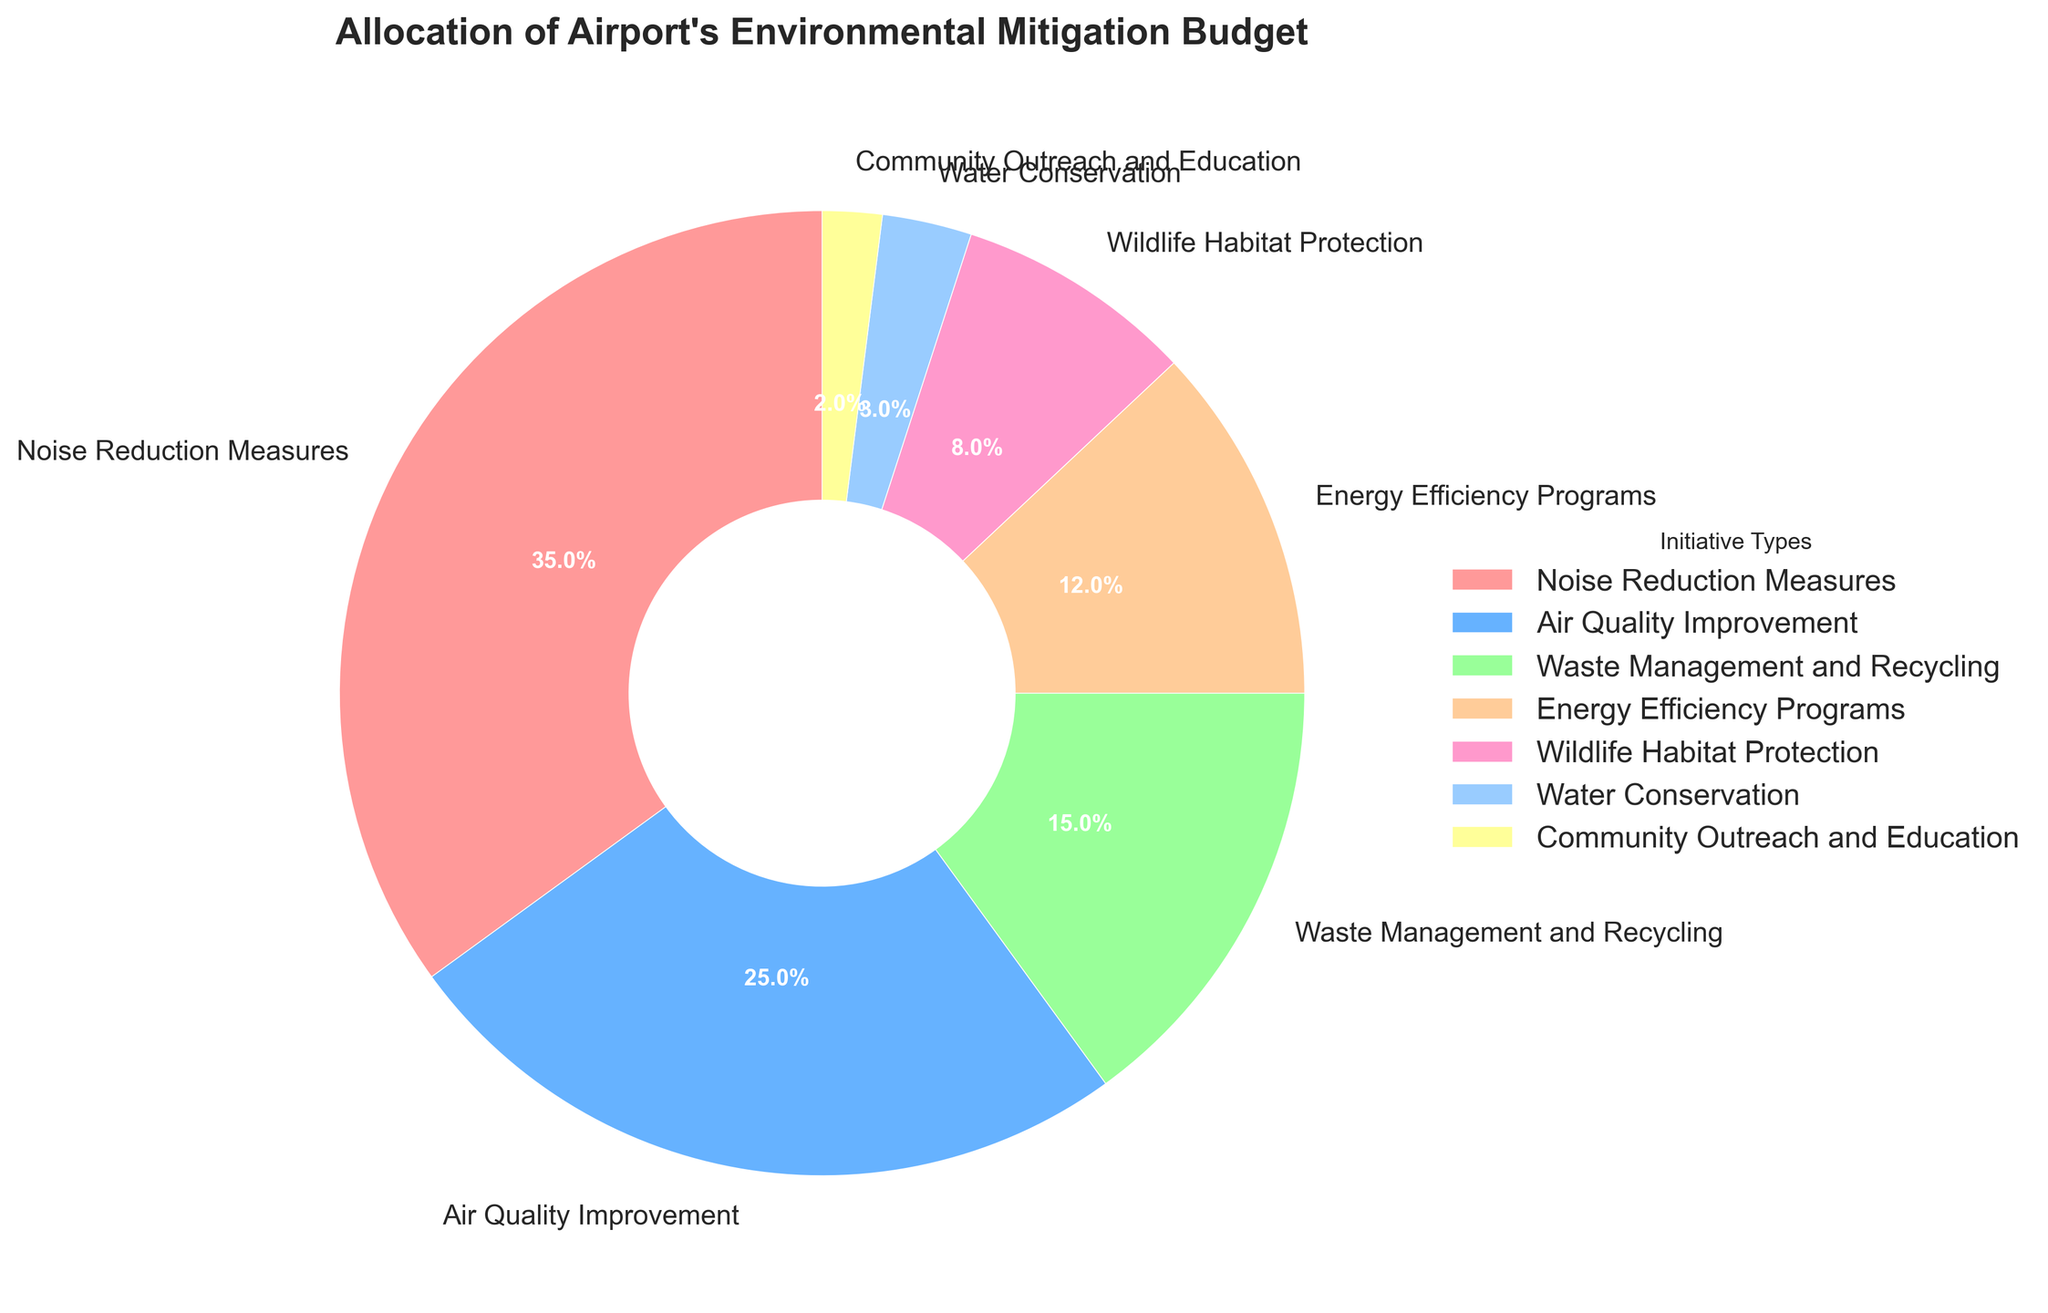Which initiative type receives the largest portion of the budget allocation? The pie chart shows that 'Noise Reduction Measures' has the biggest slice.
Answer: Noise Reduction Measures What is the combined budget allocation for Waste Management and Recycling and Energy Efficiency Programs? Add the budget allocations for Waste Management and Recycling (15%) and Energy Efficiency Programs (12%). This amounts to 15% + 12% = 27%.
Answer: 27% Are there any initiative types that have less than 5% budget allocation? The pie chart shows that 'Water Conservation' (3%) and 'Community Outreach and Education' (2%) both have less than 5%.
Answer: Yes Which has a higher budget allocation: Wildlife Habitat Protection or Air Quality Improvement? The budget allocation for Air Quality Improvement is 25%, and for Wildlife Habitat Protection, it is 8%. 25% is greater than 8%.
Answer: Air Quality Improvement What percentage of the budget is allocated for Water Conservation and Community Outreach and Education combined? Add the budget allocations for Water Conservation (3%) and Community Outreach and Education (2%). This equals 3% + 2% = 5%.
Answer: 5% How does the budget for Noise Reduction Measures compare to the budget for Energy Efficiency Programs? The budget for Noise Reduction Measures is 35%, while for Energy Efficiency Programs, it is 12%. 35% is greater than 12%.
Answer: Noise Reduction Measures has a greater budget What is the difference in budget allocation between the largest and smallest initiative types? The largest budget is for Noise Reduction Measures (35%), and the smallest is for Community Outreach and Education (2%). Subtract 2% from 35%, giving 35% - 2% = 33%.
Answer: 33% Which color represents the budget allocation for Waste Management and Recycling? The pie chart uses different colors for different initiatives. 'Waste Management and Recycling' is represented by the pinkish-orange slice.
Answer: Pinkish-orange What is the proportion of the budget dedicated to Wildlife Habitat Protection compared to the total budget allocated for Air Quality Improvement and Noise Reduction Measures? The Wildlife Habitat Protection budget is 8%. The combined budget for Air Quality Improvement (25%) and Noise Reduction Measures (35%) is 25% + 35% = 60%. To find the proportion, divide 8% by 60% which equals 8/60 = 0.1333 or approximately 13.33%.
Answer: 13.33% Which initiative type has the second largest budget allocation? The pie chart shows that the second largest slice belongs to 'Air Quality Improvement' with 25%.
Answer: Air Quality Improvement 